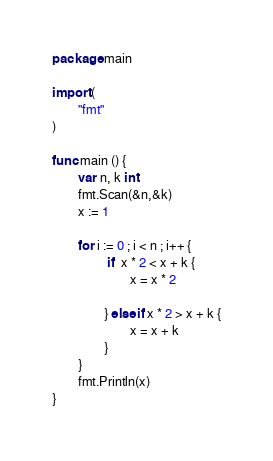<code> <loc_0><loc_0><loc_500><loc_500><_Go_>package main 

import (
        "fmt"
)

func main () {
        var n, k int
        fmt.Scan(&n,&k)
        x := 1

        for i := 0 ; i < n ; i++ {
                 if  x * 2 < x + k {
                        x = x * 2
                        
                } else if x * 2 > x + k {
                        x = x + k
                }
        }
        fmt.Println(x)
}
</code> 